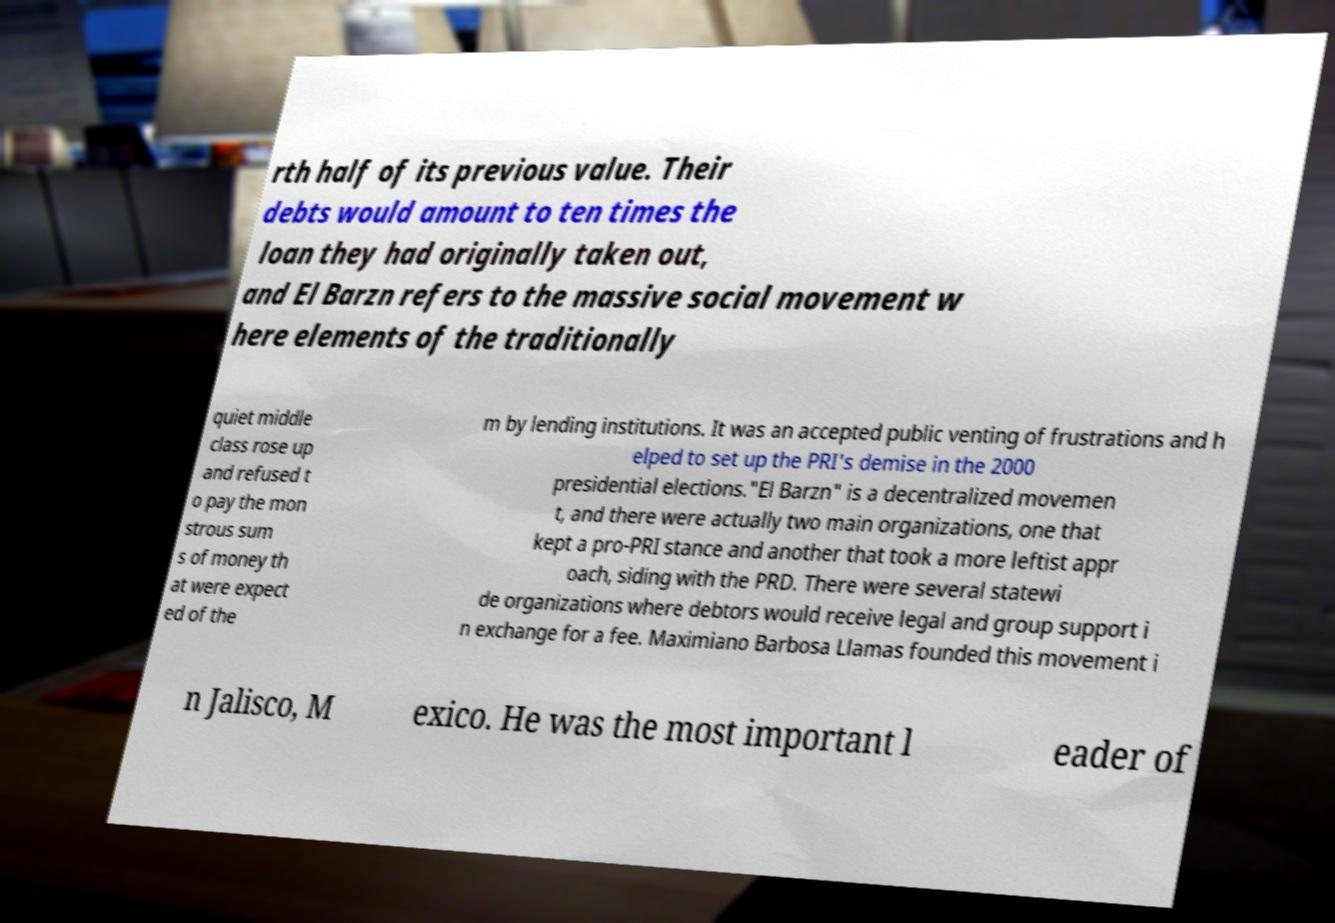I need the written content from this picture converted into text. Can you do that? rth half of its previous value. Their debts would amount to ten times the loan they had originally taken out, and El Barzn refers to the massive social movement w here elements of the traditionally quiet middle class rose up and refused t o pay the mon strous sum s of money th at were expect ed of the m by lending institutions. It was an accepted public venting of frustrations and h elped to set up the PRI's demise in the 2000 presidential elections."El Barzn" is a decentralized movemen t, and there were actually two main organizations, one that kept a pro-PRI stance and another that took a more leftist appr oach, siding with the PRD. There were several statewi de organizations where debtors would receive legal and group support i n exchange for a fee. Maximiano Barbosa Llamas founded this movement i n Jalisco, M exico. He was the most important l eader of 